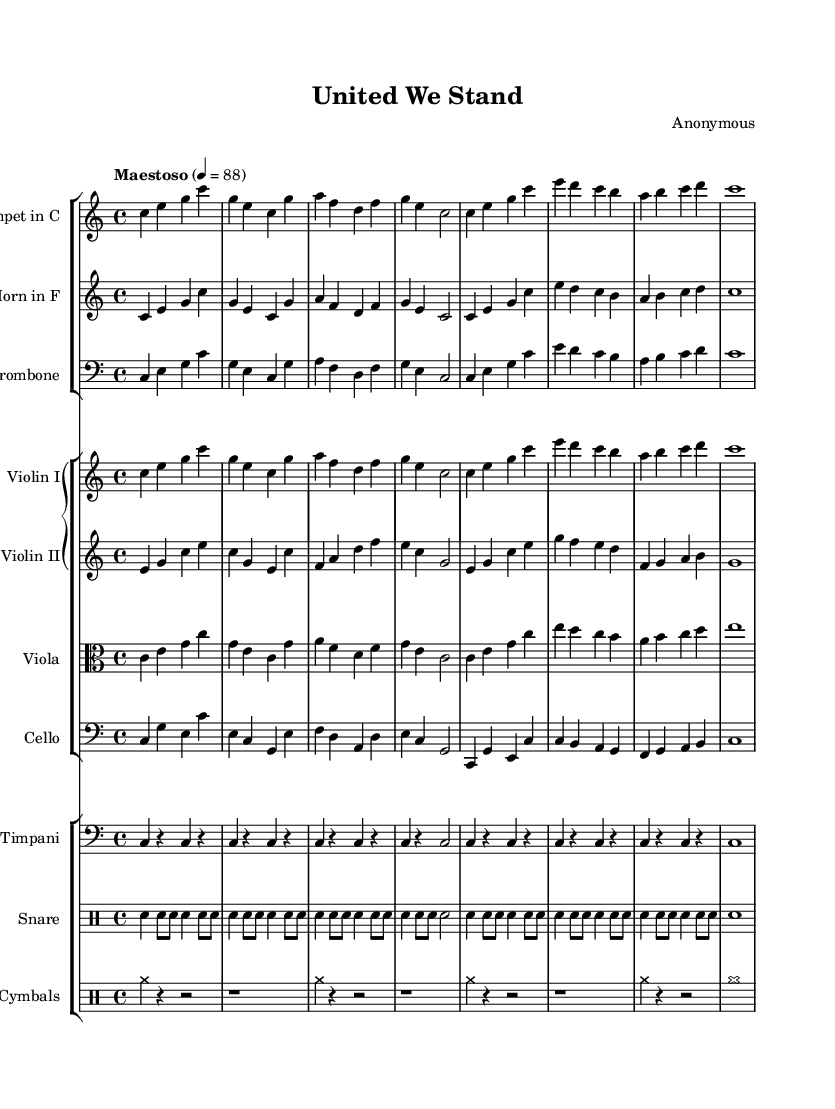What is the key signature of this music? The key signature is C major, which is represented by having no sharps or flats indicated at the beginning of the staff.
Answer: C major What is the time signature of this piece? The time signature is shown as 4/4, meaning there are four beats in each measure and the quarter note gets one beat. This is marked in the initial part of the score.
Answer: 4/4 What is the tempo marking for this music? The tempo marking is written as "Maestoso" with a metronome marking of 88, indicating it should be played majestically at a speed of 88 beats per minute.
Answer: Maestoso, 88 How many different instrument groups are in this score? The score includes three distinct groups: brass, strings, and percussion. Each group has different instruments arranged for a comparison of timbres and textures.
Answer: Three Which instruments are in the brass section? The brass section consists of the trumpet in C, French horn in F, and trombone. These instruments are listed in their own specific staff group.
Answer: Trumpet, French horn, Trombone What is the rhythmic pattern of the snare drum in the first measure? The snare drum follows a rhythmic pattern of one quarter note followed by four eighth notes, providing a march-like drive characteristic of patriotic music.
Answer: One quarter note, four eighth notes Which instruments are playing the melody in the first section? The melody is primarily played by the trumpet in C and Violin I, showcased in the treble clef and marked by the thematic material throughout the initial part of the piece.
Answer: Trumpet, Violin I 